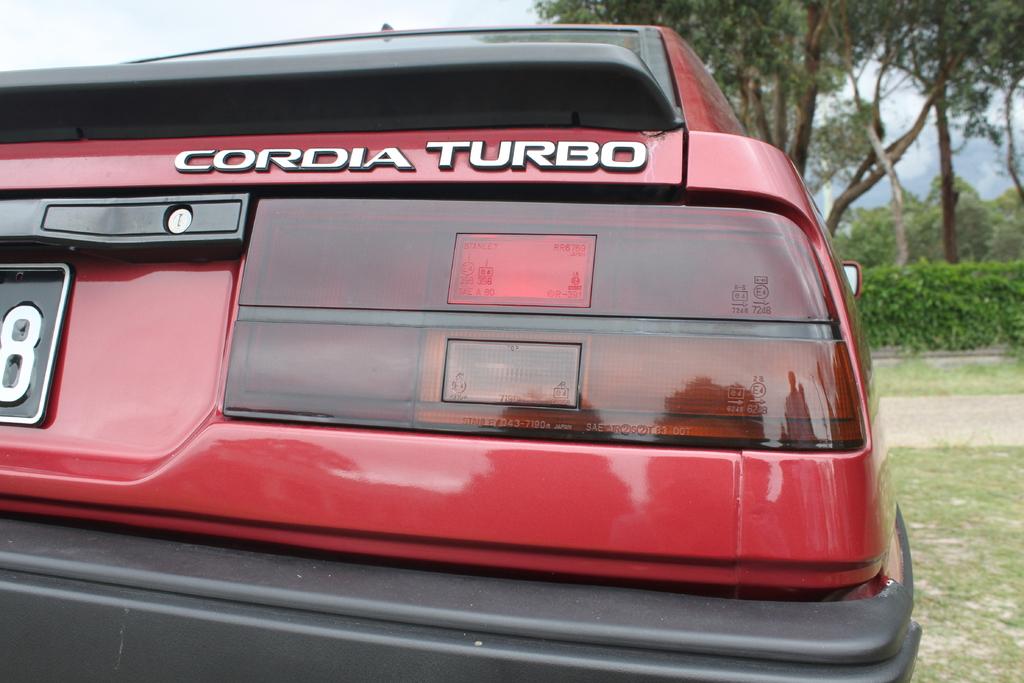What is the last digit on the plate?
Give a very brief answer. 8. Is this a cordia turbo?
Offer a terse response. Yes. 